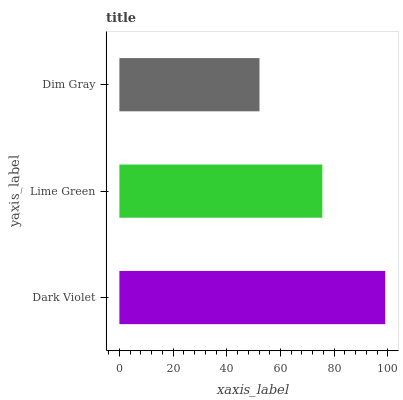Is Dim Gray the minimum?
Answer yes or no. Yes. Is Dark Violet the maximum?
Answer yes or no. Yes. Is Lime Green the minimum?
Answer yes or no. No. Is Lime Green the maximum?
Answer yes or no. No. Is Dark Violet greater than Lime Green?
Answer yes or no. Yes. Is Lime Green less than Dark Violet?
Answer yes or no. Yes. Is Lime Green greater than Dark Violet?
Answer yes or no. No. Is Dark Violet less than Lime Green?
Answer yes or no. No. Is Lime Green the high median?
Answer yes or no. Yes. Is Lime Green the low median?
Answer yes or no. Yes. Is Dim Gray the high median?
Answer yes or no. No. Is Dark Violet the low median?
Answer yes or no. No. 